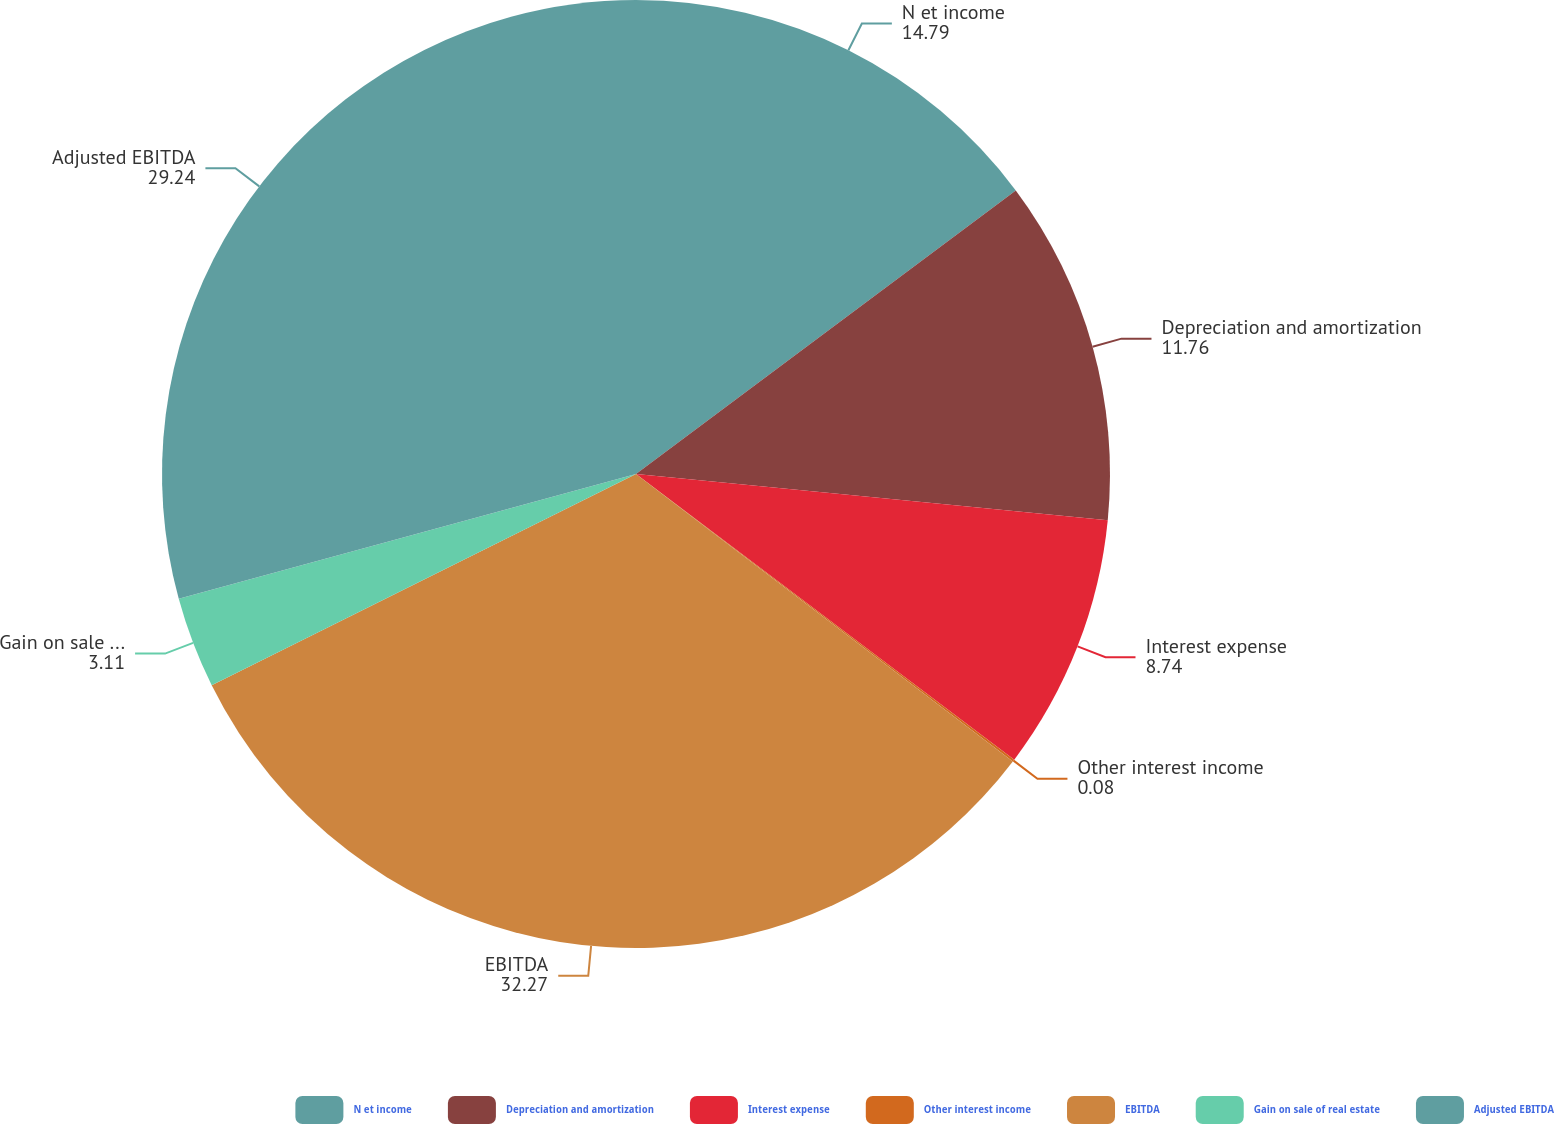Convert chart to OTSL. <chart><loc_0><loc_0><loc_500><loc_500><pie_chart><fcel>N et income<fcel>Depreciation and amortization<fcel>Interest expense<fcel>Other interest income<fcel>EBITDA<fcel>Gain on sale of real estate<fcel>Adjusted EBITDA<nl><fcel>14.79%<fcel>11.76%<fcel>8.74%<fcel>0.08%<fcel>32.27%<fcel>3.11%<fcel>29.24%<nl></chart> 